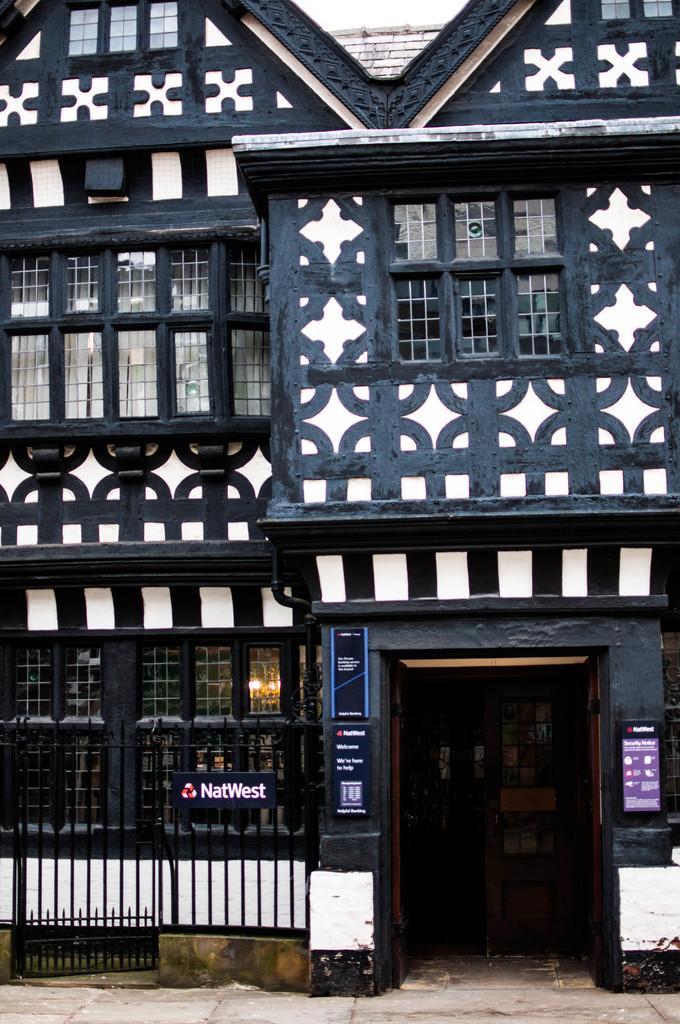How would you summarize this image in a sentence or two? This picture shows a building and we see few boards on the wall and a wooden door and we see a metal fence. 